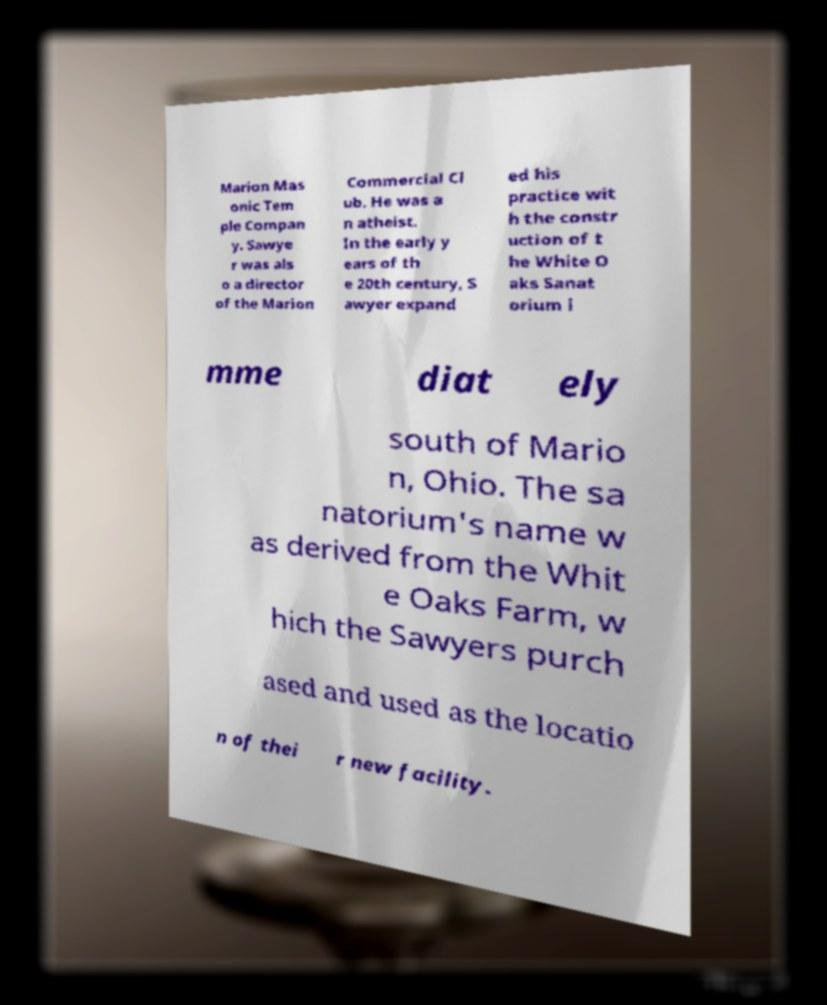Could you extract and type out the text from this image? Marion Mas onic Tem ple Compan y. Sawye r was als o a director of the Marion Commercial Cl ub. He was a n atheist. In the early y ears of th e 20th century, S awyer expand ed his practice wit h the constr uction of t he White O aks Sanat orium i mme diat ely south of Mario n, Ohio. The sa natorium's name w as derived from the Whit e Oaks Farm, w hich the Sawyers purch ased and used as the locatio n of thei r new facility. 